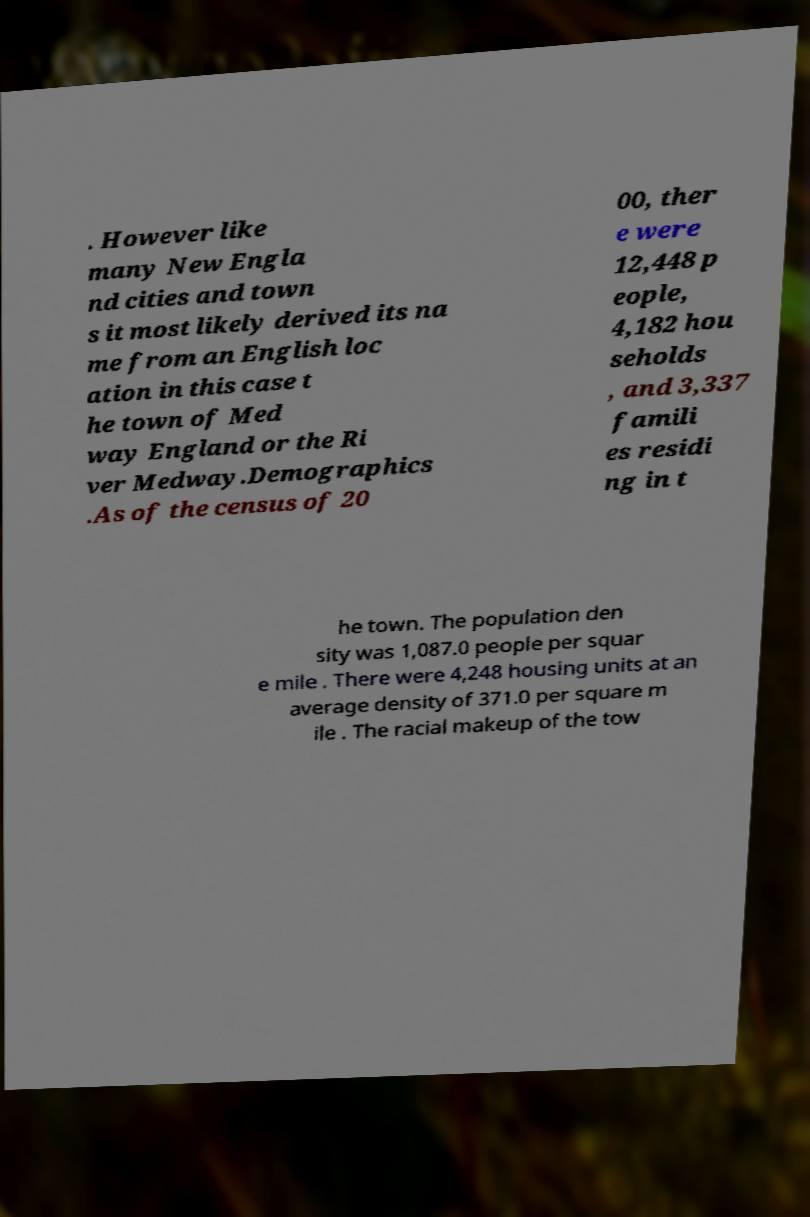Can you read and provide the text displayed in the image?This photo seems to have some interesting text. Can you extract and type it out for me? . However like many New Engla nd cities and town s it most likely derived its na me from an English loc ation in this case t he town of Med way England or the Ri ver Medway.Demographics .As of the census of 20 00, ther e were 12,448 p eople, 4,182 hou seholds , and 3,337 famili es residi ng in t he town. The population den sity was 1,087.0 people per squar e mile . There were 4,248 housing units at an average density of 371.0 per square m ile . The racial makeup of the tow 